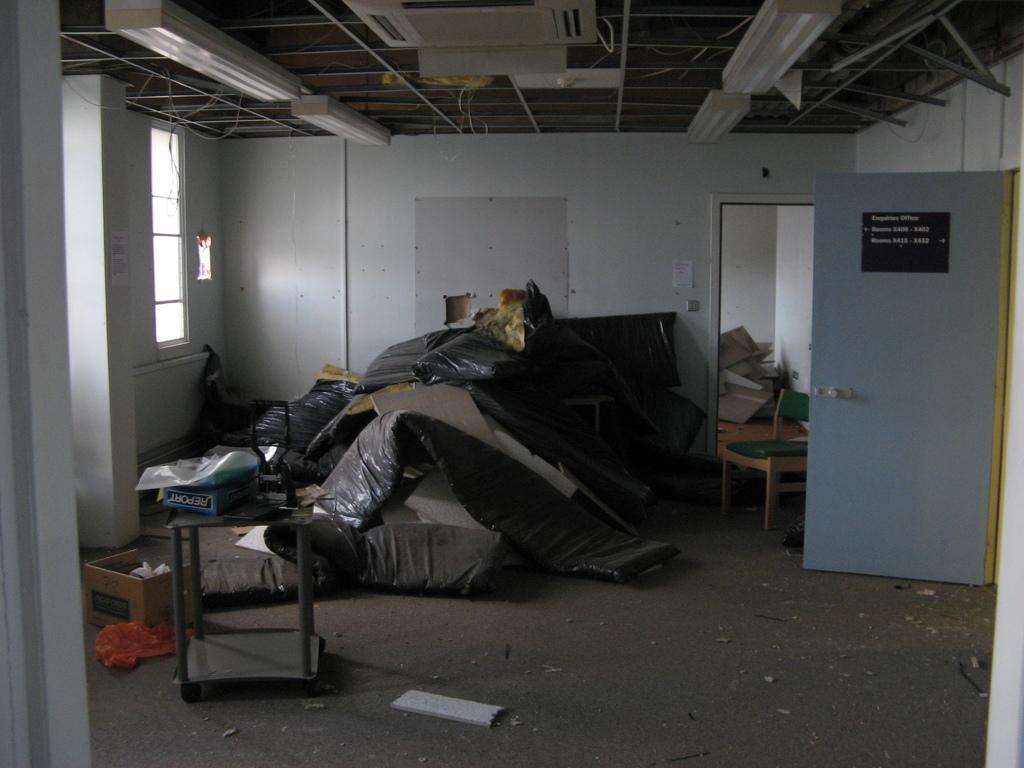Could you give a brief overview of what you see in this image? In this image we can see a room. In the room there is a cardboard box, table, chair and few other objects. On the right side there is a door. On the door there is a board with something written. In the back there is a wall and an entrance to other room. On the left side there is a window. On the table there is a box and some other items. On the ceiling we can see tube lights. Also there are rods. 